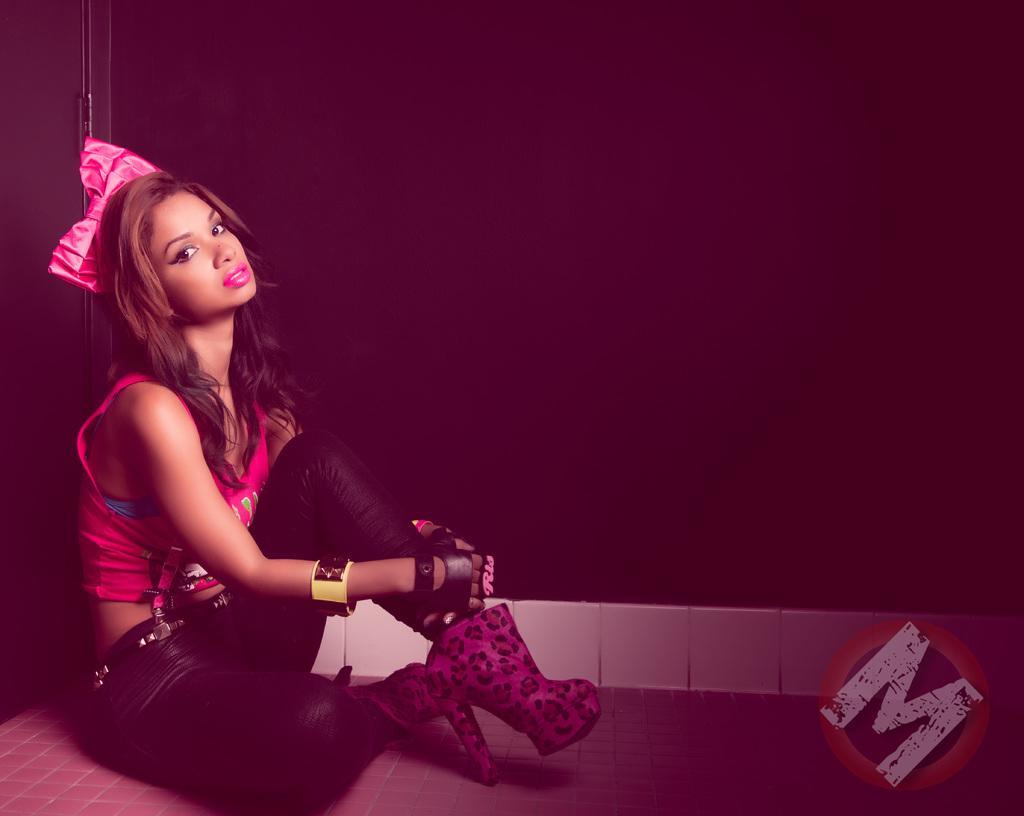How would you summarize this image in a sentence or two? In the center of the image there is a woman sitting on the ground. In the background there is wall. 